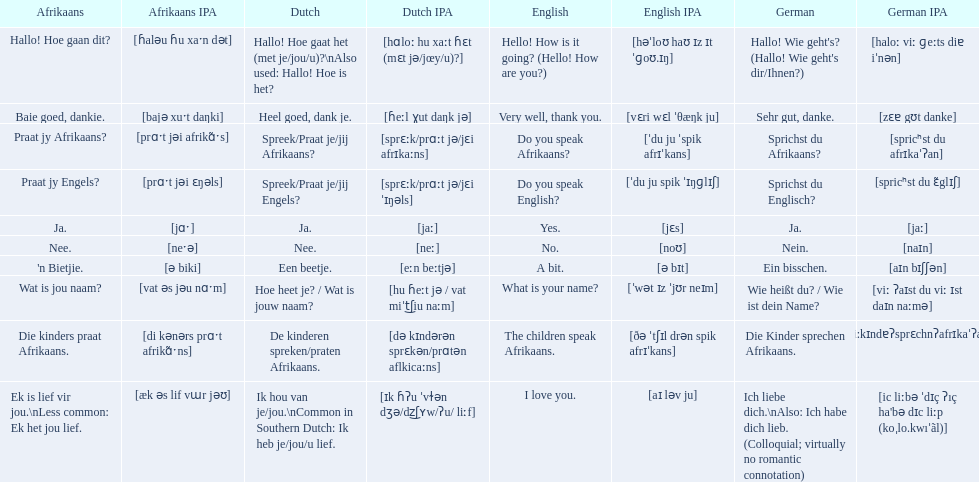Can you parse all the data within this table? {'header': ['Afrikaans', 'Afrikaans IPA', 'Dutch', 'Dutch IPA', 'English', 'English IPA', 'German', 'German IPA'], 'rows': [['Hallo! Hoe gaan dit?', '[ɦaləu ɦu xaˑn dət]', 'Hallo! Hoe gaat het (met je/jou/u)?\\nAlso used: Hallo! Hoe is het?', '[hɑloː hu xaːt ɦɛt (mɛt jə/jœy/u)?]', 'Hello! How is it going? (Hello! How are you?)', '[həˈloʊ haʊ ɪz ɪt ˈɡoʊ.ɪŋ]', "Hallo! Wie geht's? (Hallo! Wie geht's dir/Ihnen?)", '[haloː viː ɡeːts diɐ iˈnən]'], ['Baie goed, dankie.', '[bajə xuˑt daŋki]', 'Heel goed, dank je.', '[ɦeːl ɣut daŋk jə]', 'Very well, thank you.', '[vɛri wɛl ˈθæŋk ju]', 'Sehr gut, danke.', '[zɛɐ gʊt danke]'], ['Praat jy Afrikaans?', '[prɑˑt jəi afrikɑ̃ˑs]', 'Spreek/Praat je/jij Afrikaans?', '[sprɛːk/prɑːt jə/jɛi afrɪkaːns]', 'Do you speak Afrikaans?', '[ˈdu ju ˈspik afrɪˈkans]', 'Sprichst du Afrikaans?', '[spricʰst du afrɪkaˈʔan]'], ['Praat jy Engels?', '[prɑˑt jəi ɛŋəls]', 'Spreek/Praat je/jij Engels?', '[sprɛːk/prɑːt jə/jɛi ˈɪŋəls]', 'Do you speak English?', '[ˈdu ju spik ˈɪŋɡlɪʃ]', 'Sprichst du Englisch?', '[spricʰst du ɛ̃glɪʃ]'], ['Ja.', '[jɑˑ]', 'Ja.', '[jaː]', 'Yes.', '[jɛs]', 'Ja.', '[jaː]'], ['Nee.', '[neˑə]', 'Nee.', '[neː]', 'No.', '[noʊ]', 'Nein.', '[naɪn]'], ["'n Bietjie.", '[ə biki]', 'Een beetje.', '[eːn beːtjə]', 'A bit.', '[ə bɪt]', 'Ein bisschen.', '[aɪn bɪʃʃən]'], ['Wat is jou naam?', '[vat əs jəu nɑˑm]', 'Hoe heet je? / Wat is jouw naam?', '[hu ɦeːt jə / vat miˈt͜ʃiu naːm]', 'What is your name?', '[ˈwət ɪz ˈjʊr neɪm]', 'Wie heißt du? / Wie ist dein Name?', '[viː ʔaɪst du viː ɪst daɪn naːmə]'], ['Die kinders praat Afrikaans.', '[di kənərs prɑˑt afrikɑ̃ˑns]', 'De kinderen spreken/praten Afrikaans.', '[də kɪndərən sprɛkən/prɑtən aflkicaːns]', 'The children speak Afrikaans.', '[ðə ˈtʃɪl drən spik afrɪˈkans]', 'Die Kinder sprechen Afrikaans.', '[di:kɪndɐʔsprɛchnʔafrɪkaˈʔan]'], ['Ek is lief vir jou.\\nLess common: Ek het jou lief.', '[æk əs lif vɯr jəʊ]', 'Ik hou van je/jou.\\nCommon in Southern Dutch: Ik heb je/jou/u lief.', '[ɪk ɦʔu ˈvɫən dʒə/dz͜ʃʏw/ʔu/ liːf]', 'I love you.', '[aɪ ləv ju]', 'Ich liebe dich.\\nAlso: Ich habe dich lieb. (Colloquial; virtually no romantic connotation)', "[ic liːbə ˈdɪç ʔıç ha'bə dɪc liːp (koˌlo.kwıˈãl)]"]]} How would you say the phrase the children speak afrikaans in afrikaans? Die kinders praat Afrikaans. How would you say the previous phrase in german? Die Kinder sprechen Afrikaans. 